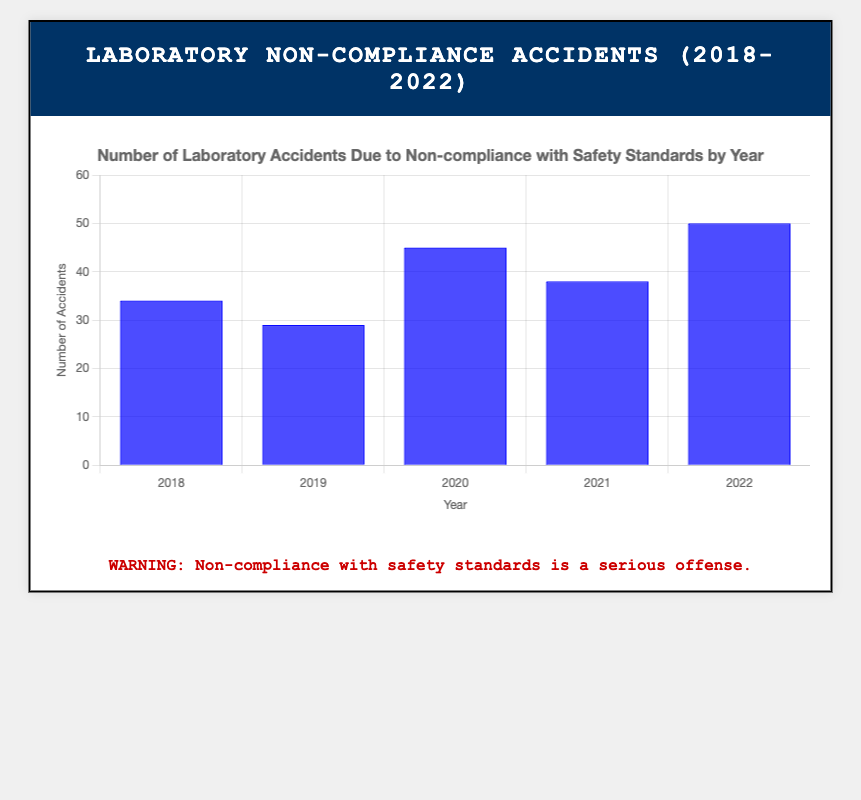What year recorded the highest number of non-compliance accidents? From the bar chart, look for the tallest bar. The tallest bar represents the year 2022 with 50 accidents.
Answer: 2022 How many non-compliance accidents were recorded in total from 2018 to 2022? Add the number of accidents for each year: 34 (2018) + 29 (2019) + 45 (2020) + 38 (2021) + 50 (2022) = 196.
Answer: 196 What was the difference in non-compliance accidents between the years 2020 and 2019? Subtract the accidents in 2019 from those in 2020: 45 (2020) - 29 (2019) = 16.
Answer: 16 Which year experienced fewer non-compliance accidents: 2018 or 2021? Compare the bars for 2018 and 2021. The bar for 2018 represents 34 accidents while the bar for 2021 represents 38 accidents. Therefore, 2018 had fewer accidents.
Answer: 2018 What is the increase in non-compliance accidents from 2021 to 2022? Subtract the number of accidents in 2021 from those in 2022: 50 (2022) - 38 (2021) = 12.
Answer: 12 Calculate the average number of non-compliance accidents per year over the 5-year period. Sum the accidents from 2018 to 2022, which is 196, and then divide by 5. 196 / 5 = 39.2.
Answer: 39.2 Between which two consecutive years did the number of non-compliance accidents increase the most? Calculate the difference for each consecutive year pair: 2019-2018: -5, 2020-2019: 16, 2021-2020: -7, 2022-2021: 12. The largest increase occurred between 2019 and 2020 with an increase of 16 accidents.
Answer: 2019 and 2020 What is the trend in the number of non-compliance accidents from 2018 to 2022? Observe the direction of the bars from left to right: slight decrease from 2018 to 2019, significant increase in 2020, slight decrease in 2021, and then a peak in 2022. The overall trend shows an increase.
Answer: Increasing How many more non-compliance accidents were there in 2022 compared to 2018? Subtract the number of accidents in 2018 from those in 2022: 50 (2022) - 34 (2018) = 16.
Answer: 16 